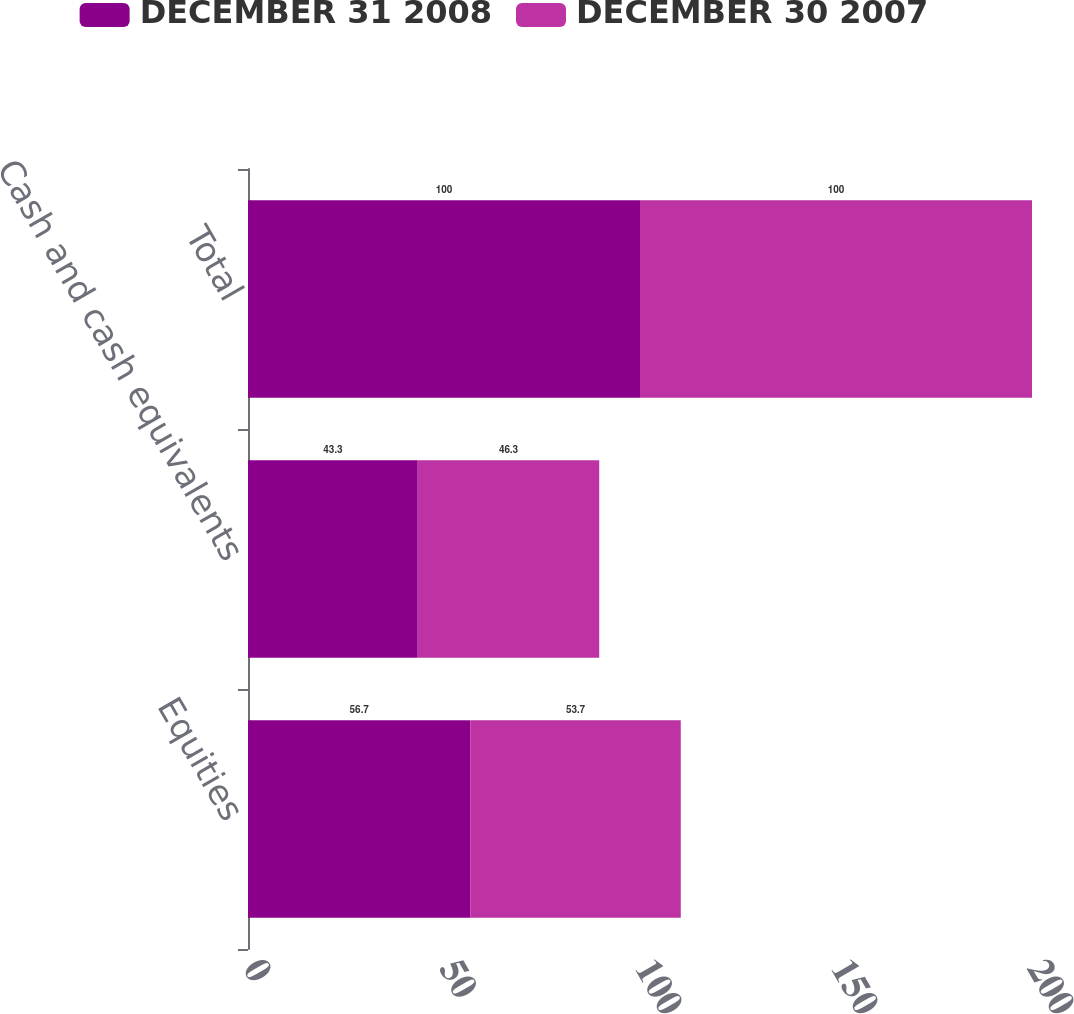Convert chart. <chart><loc_0><loc_0><loc_500><loc_500><stacked_bar_chart><ecel><fcel>Equities<fcel>Cash and cash equivalents<fcel>Total<nl><fcel>DECEMBER 31 2008<fcel>56.7<fcel>43.3<fcel>100<nl><fcel>DECEMBER 30 2007<fcel>53.7<fcel>46.3<fcel>100<nl></chart> 